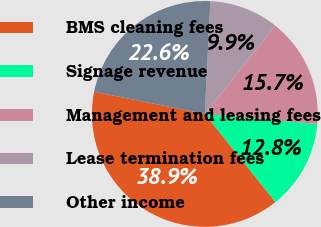<chart> <loc_0><loc_0><loc_500><loc_500><pie_chart><fcel>BMS cleaning fees<fcel>Signage revenue<fcel>Management and leasing fees<fcel>Lease termination fees<fcel>Other income<nl><fcel>38.89%<fcel>12.82%<fcel>15.72%<fcel>9.93%<fcel>22.63%<nl></chart> 